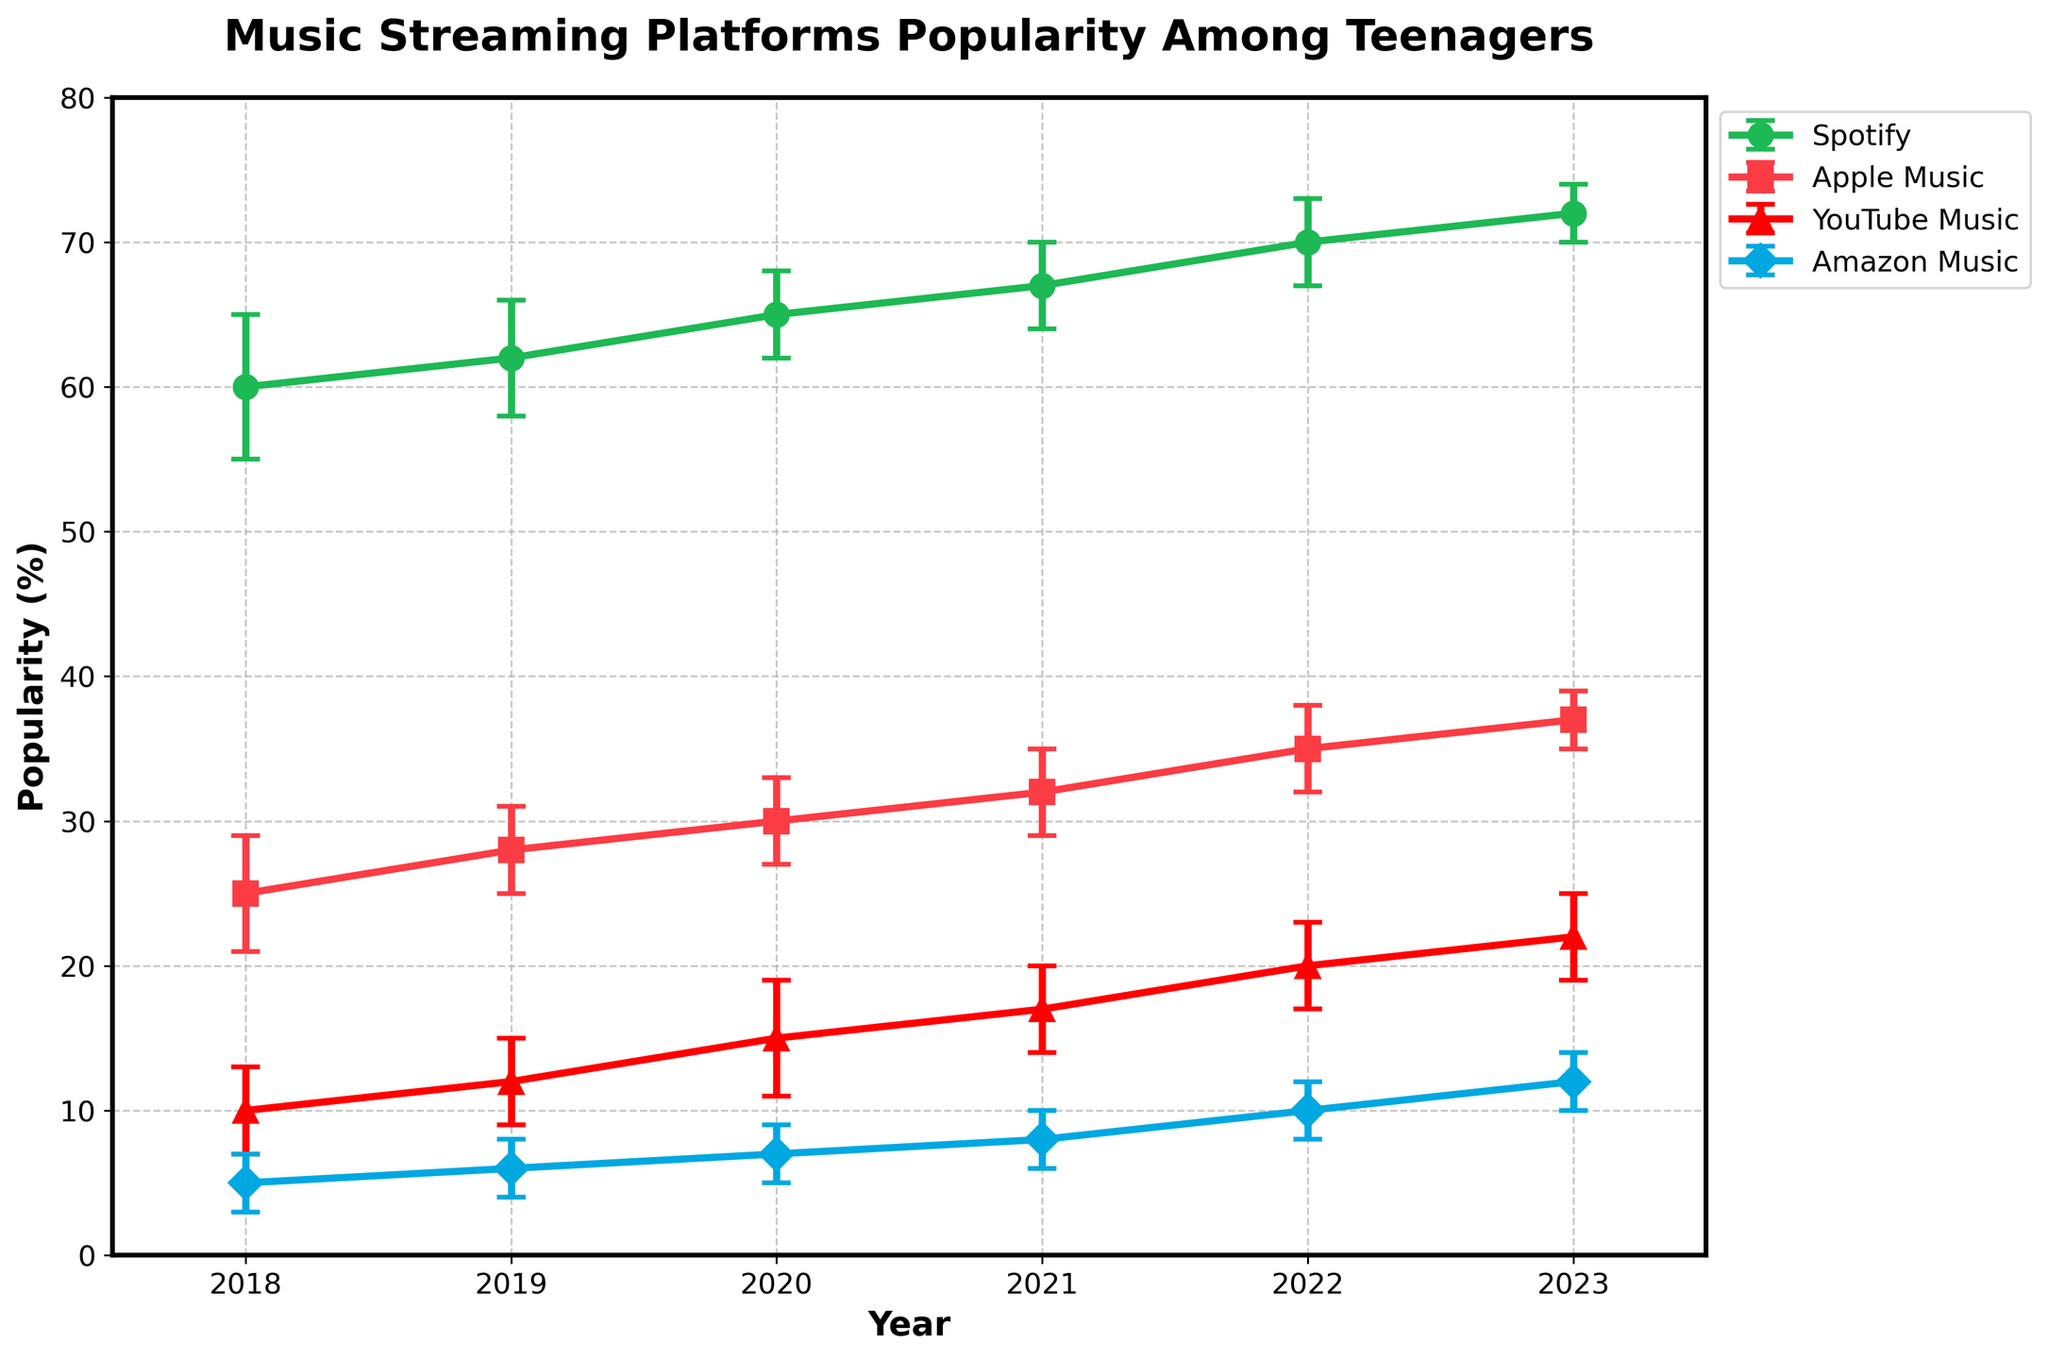what's the title of the figure? The title of the figure is displayed at the top of the graph. It should summarize the overall content of the figure.
Answer: Music Streaming Platforms Popularity Among Teenagers which platform had the highest popularity in 2022? The data points for each platform in 2022 can be compared. The highest value corresponds to the most popular platform.
Answer: Spotify what is the range of error values for YouTube Music in 2021? Range of error values can be found by looking at the error bars extending above and below the data point. For 2021, check the value of the error bars.
Answer: 3 How did Spotify's popularity change from 2018 to 2023? Compare the data points for Spotify from 2018 to 2023 to see the increasing or decreasing trend.
Answer: Increased by 12% which platform had the smallest error bar range in 2023? Look at the lengths of the error bars for all platforms in 2023 and identify the shortest one.
Answer: Spotify In 2020, which platform was preferred more by teenagers, Apple Music or YouTube Music? Compare the popularity percentage values for Apple Music and YouTube Music in 2020.
Answer: Apple Music which years show the highest and lowest popularity for Amazon Music? Review the popularity values for Amazon Music across all years and identify the highest and lowest values.
Answer: Highest: 2023, Lowest: 2018 What was the average popularity of Apple Music from 2018 to 2023? To find the average, sum up the popularity percentages of Apple Music from 2018 to 2023 and then divide by the number of years. So, (25+28+30+32+35+37) / 6 = 187 / 6 = 31.17.
Answer: 31.17% which platform showed the steadiest increase in popularity over the years? By visual inspection and data comparison, determine which platform's trend line shows a consistent increase without fluctuations.
Answer: Spotify 